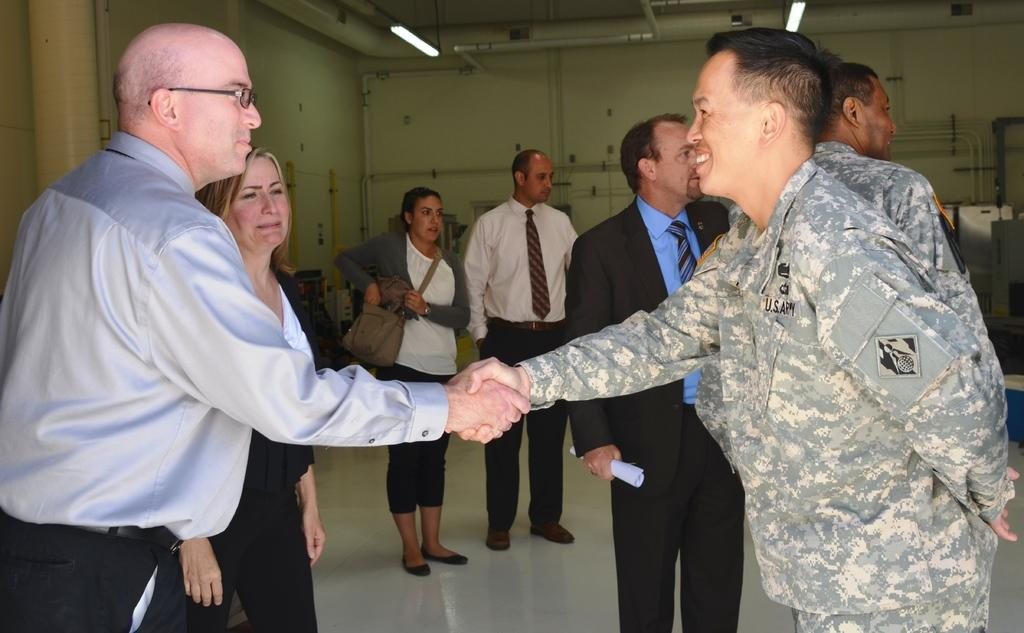What is the main subject of the image? The main subject of the image is a group of people. What are the people in the image doing? The people are standing and smiling. What can be seen in the background of the image? There are lights and a wall visible in the image. What type of fuel is being used by the committee in the image? There is no committee or fuel present in the image; it features a group of people standing and smiling. What observation can be made about the people's behavior in the image? The people in the image are smiling, which suggests a positive or happy mood. 